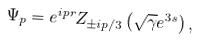<formula> <loc_0><loc_0><loc_500><loc_500>\Psi _ { p } = e ^ { i p r } Z _ { \pm i p / 3 } \left ( \sqrt { \gamma } e ^ { 3 s } \right ) ,</formula> 